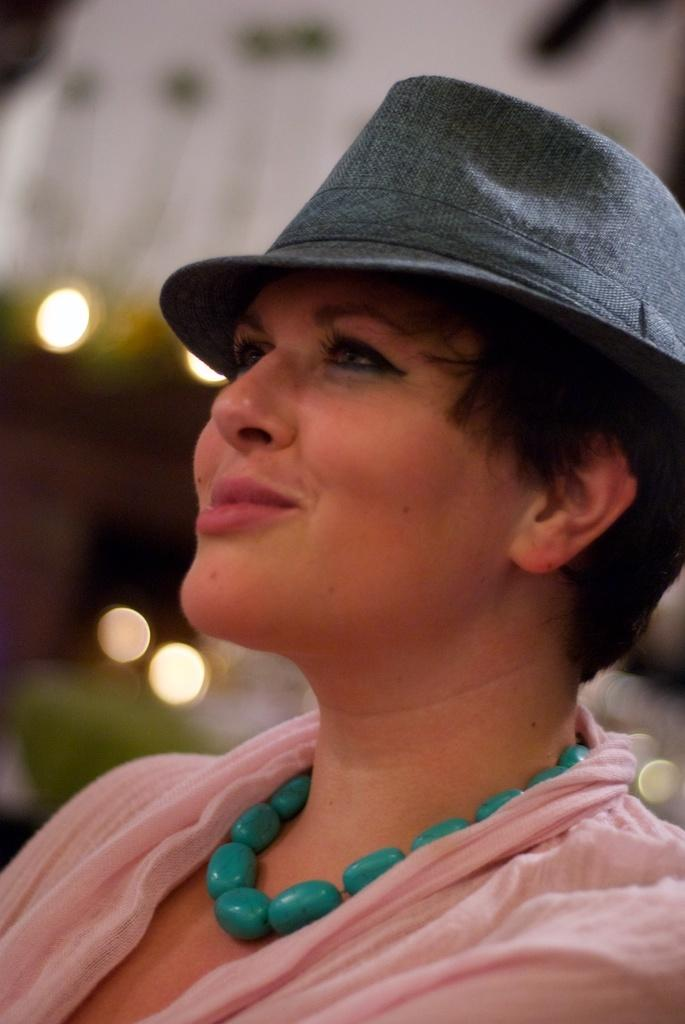Who is the main subject in the image? There is a woman in the image. What is the woman wearing? The woman is wearing a pink dress and a grey cowboy cap. What is the woman doing in the image? The woman is sitting. What is the woman's facial expression in the image? The woman is smiling. Can you see any boats in the harbor in the image? There is no harbor or boats present in the image; it features a woman sitting and smiling. What type of haircut does the woman have in the image? The provided facts do not mention the woman's haircut, so it cannot be determined from the image. 